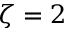Convert formula to latex. <formula><loc_0><loc_0><loc_500><loc_500>\zeta = 2</formula> 